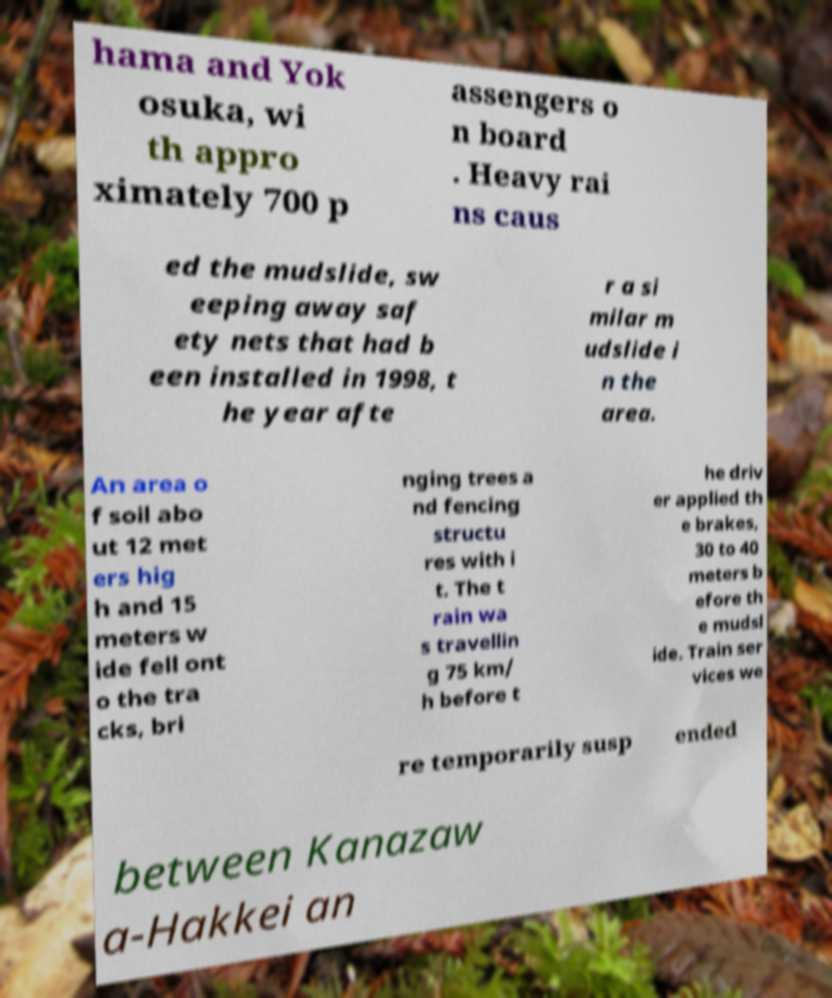Please read and relay the text visible in this image. What does it say? hama and Yok osuka, wi th appro ximately 700 p assengers o n board . Heavy rai ns caus ed the mudslide, sw eeping away saf ety nets that had b een installed in 1998, t he year afte r a si milar m udslide i n the area. An area o f soil abo ut 12 met ers hig h and 15 meters w ide fell ont o the tra cks, bri nging trees a nd fencing structu res with i t. The t rain wa s travellin g 75 km/ h before t he driv er applied th e brakes, 30 to 40 meters b efore th e mudsl ide. Train ser vices we re temporarily susp ended between Kanazaw a-Hakkei an 